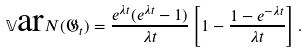<formula> <loc_0><loc_0><loc_500><loc_500>\mathbb { V } \text {ar} N ( \mathfrak { G } _ { t } ) = \frac { e ^ { \lambda t } ( e ^ { \lambda t } - 1 ) } { \lambda t } \left [ 1 - \frac { 1 - e ^ { - \lambda t } } { \lambda t } \right ] .</formula> 